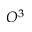Convert formula to latex. <formula><loc_0><loc_0><loc_500><loc_500>O ^ { 3 }</formula> 